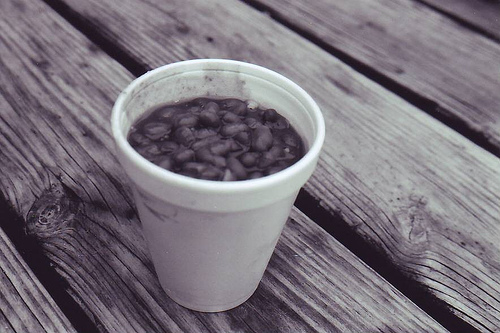<image>
Can you confirm if the beans is on the deck? Yes. Looking at the image, I can see the beans is positioned on top of the deck, with the deck providing support. 